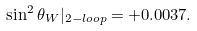Convert formula to latex. <formula><loc_0><loc_0><loc_500><loc_500>\sin ^ { 2 } \theta _ { W } | _ { 2 - l o o p } = + 0 . 0 0 3 7 .</formula> 